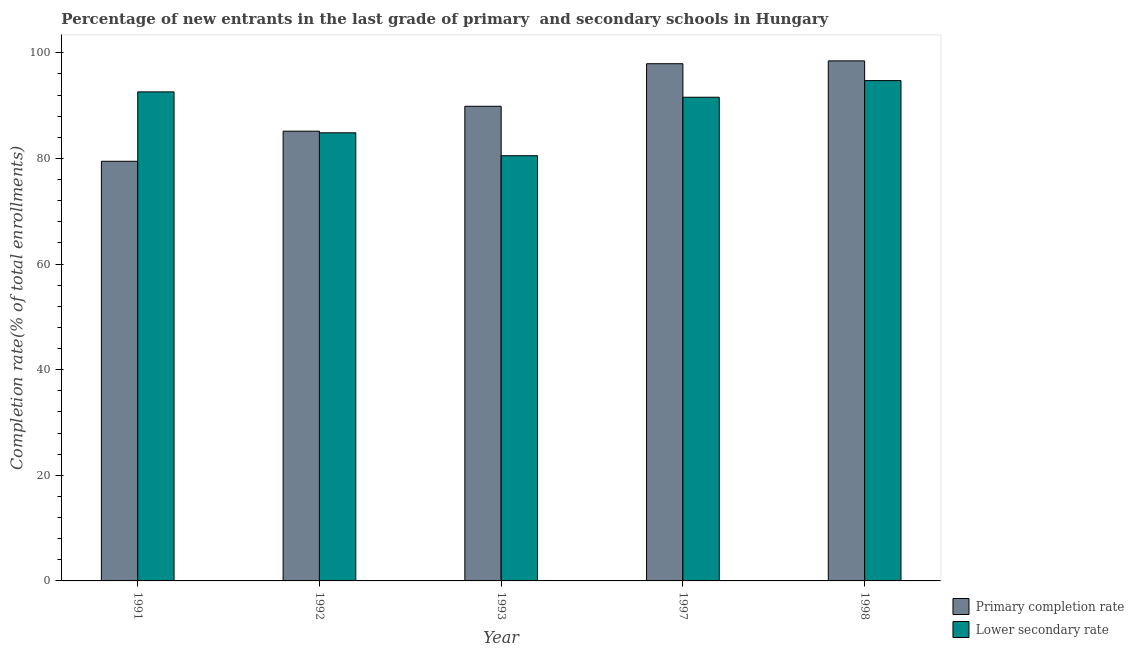How many different coloured bars are there?
Keep it short and to the point. 2. Are the number of bars per tick equal to the number of legend labels?
Give a very brief answer. Yes. How many bars are there on the 2nd tick from the left?
Keep it short and to the point. 2. What is the label of the 3rd group of bars from the left?
Your answer should be compact. 1993. In how many cases, is the number of bars for a given year not equal to the number of legend labels?
Give a very brief answer. 0. What is the completion rate in primary schools in 1992?
Your answer should be compact. 85.17. Across all years, what is the maximum completion rate in secondary schools?
Your response must be concise. 94.74. Across all years, what is the minimum completion rate in primary schools?
Your answer should be very brief. 79.47. In which year was the completion rate in secondary schools maximum?
Your answer should be very brief. 1998. In which year was the completion rate in secondary schools minimum?
Keep it short and to the point. 1993. What is the total completion rate in secondary schools in the graph?
Your answer should be compact. 444.32. What is the difference between the completion rate in secondary schools in 1991 and that in 1992?
Ensure brevity in your answer.  7.75. What is the difference between the completion rate in secondary schools in 1991 and the completion rate in primary schools in 1992?
Provide a succinct answer. 7.75. What is the average completion rate in secondary schools per year?
Make the answer very short. 88.86. In the year 1998, what is the difference between the completion rate in secondary schools and completion rate in primary schools?
Offer a terse response. 0. What is the ratio of the completion rate in secondary schools in 1997 to that in 1998?
Offer a terse response. 0.97. Is the difference between the completion rate in primary schools in 1991 and 1998 greater than the difference between the completion rate in secondary schools in 1991 and 1998?
Make the answer very short. No. What is the difference between the highest and the second highest completion rate in primary schools?
Your response must be concise. 0.54. What is the difference between the highest and the lowest completion rate in primary schools?
Your answer should be very brief. 19.01. What does the 1st bar from the left in 1991 represents?
Make the answer very short. Primary completion rate. What does the 2nd bar from the right in 1997 represents?
Your answer should be compact. Primary completion rate. How many years are there in the graph?
Offer a terse response. 5. Where does the legend appear in the graph?
Your answer should be very brief. Bottom right. How many legend labels are there?
Your response must be concise. 2. How are the legend labels stacked?
Offer a terse response. Vertical. What is the title of the graph?
Make the answer very short. Percentage of new entrants in the last grade of primary  and secondary schools in Hungary. Does "Research and Development" appear as one of the legend labels in the graph?
Ensure brevity in your answer.  No. What is the label or title of the Y-axis?
Provide a succinct answer. Completion rate(% of total enrollments). What is the Completion rate(% of total enrollments) of Primary completion rate in 1991?
Your answer should be very brief. 79.47. What is the Completion rate(% of total enrollments) of Lower secondary rate in 1991?
Make the answer very short. 92.61. What is the Completion rate(% of total enrollments) of Primary completion rate in 1992?
Ensure brevity in your answer.  85.17. What is the Completion rate(% of total enrollments) in Lower secondary rate in 1992?
Give a very brief answer. 84.86. What is the Completion rate(% of total enrollments) of Primary completion rate in 1993?
Your response must be concise. 89.88. What is the Completion rate(% of total enrollments) of Lower secondary rate in 1993?
Make the answer very short. 80.52. What is the Completion rate(% of total enrollments) in Primary completion rate in 1997?
Ensure brevity in your answer.  97.94. What is the Completion rate(% of total enrollments) of Lower secondary rate in 1997?
Your answer should be compact. 91.59. What is the Completion rate(% of total enrollments) in Primary completion rate in 1998?
Your answer should be compact. 98.48. What is the Completion rate(% of total enrollments) in Lower secondary rate in 1998?
Provide a short and direct response. 94.74. Across all years, what is the maximum Completion rate(% of total enrollments) of Primary completion rate?
Your response must be concise. 98.48. Across all years, what is the maximum Completion rate(% of total enrollments) in Lower secondary rate?
Ensure brevity in your answer.  94.74. Across all years, what is the minimum Completion rate(% of total enrollments) in Primary completion rate?
Give a very brief answer. 79.47. Across all years, what is the minimum Completion rate(% of total enrollments) of Lower secondary rate?
Offer a terse response. 80.52. What is the total Completion rate(% of total enrollments) in Primary completion rate in the graph?
Offer a very short reply. 450.93. What is the total Completion rate(% of total enrollments) in Lower secondary rate in the graph?
Offer a very short reply. 444.32. What is the difference between the Completion rate(% of total enrollments) of Primary completion rate in 1991 and that in 1992?
Give a very brief answer. -5.7. What is the difference between the Completion rate(% of total enrollments) in Lower secondary rate in 1991 and that in 1992?
Offer a very short reply. 7.75. What is the difference between the Completion rate(% of total enrollments) in Primary completion rate in 1991 and that in 1993?
Your answer should be compact. -10.42. What is the difference between the Completion rate(% of total enrollments) of Lower secondary rate in 1991 and that in 1993?
Your answer should be compact. 12.09. What is the difference between the Completion rate(% of total enrollments) in Primary completion rate in 1991 and that in 1997?
Your answer should be compact. -18.47. What is the difference between the Completion rate(% of total enrollments) in Lower secondary rate in 1991 and that in 1997?
Your response must be concise. 1.01. What is the difference between the Completion rate(% of total enrollments) in Primary completion rate in 1991 and that in 1998?
Make the answer very short. -19.01. What is the difference between the Completion rate(% of total enrollments) in Lower secondary rate in 1991 and that in 1998?
Make the answer very short. -2.14. What is the difference between the Completion rate(% of total enrollments) of Primary completion rate in 1992 and that in 1993?
Provide a succinct answer. -4.71. What is the difference between the Completion rate(% of total enrollments) in Lower secondary rate in 1992 and that in 1993?
Your answer should be compact. 4.34. What is the difference between the Completion rate(% of total enrollments) of Primary completion rate in 1992 and that in 1997?
Provide a short and direct response. -12.77. What is the difference between the Completion rate(% of total enrollments) in Lower secondary rate in 1992 and that in 1997?
Offer a very short reply. -6.74. What is the difference between the Completion rate(% of total enrollments) in Primary completion rate in 1992 and that in 1998?
Make the answer very short. -13.31. What is the difference between the Completion rate(% of total enrollments) in Lower secondary rate in 1992 and that in 1998?
Provide a short and direct response. -9.89. What is the difference between the Completion rate(% of total enrollments) of Primary completion rate in 1993 and that in 1997?
Offer a terse response. -8.06. What is the difference between the Completion rate(% of total enrollments) of Lower secondary rate in 1993 and that in 1997?
Provide a succinct answer. -11.08. What is the difference between the Completion rate(% of total enrollments) of Primary completion rate in 1993 and that in 1998?
Provide a succinct answer. -8.6. What is the difference between the Completion rate(% of total enrollments) of Lower secondary rate in 1993 and that in 1998?
Offer a very short reply. -14.23. What is the difference between the Completion rate(% of total enrollments) of Primary completion rate in 1997 and that in 1998?
Provide a short and direct response. -0.54. What is the difference between the Completion rate(% of total enrollments) in Lower secondary rate in 1997 and that in 1998?
Give a very brief answer. -3.15. What is the difference between the Completion rate(% of total enrollments) of Primary completion rate in 1991 and the Completion rate(% of total enrollments) of Lower secondary rate in 1992?
Ensure brevity in your answer.  -5.39. What is the difference between the Completion rate(% of total enrollments) in Primary completion rate in 1991 and the Completion rate(% of total enrollments) in Lower secondary rate in 1993?
Your response must be concise. -1.05. What is the difference between the Completion rate(% of total enrollments) of Primary completion rate in 1991 and the Completion rate(% of total enrollments) of Lower secondary rate in 1997?
Your answer should be compact. -12.13. What is the difference between the Completion rate(% of total enrollments) in Primary completion rate in 1991 and the Completion rate(% of total enrollments) in Lower secondary rate in 1998?
Your answer should be very brief. -15.28. What is the difference between the Completion rate(% of total enrollments) of Primary completion rate in 1992 and the Completion rate(% of total enrollments) of Lower secondary rate in 1993?
Keep it short and to the point. 4.65. What is the difference between the Completion rate(% of total enrollments) of Primary completion rate in 1992 and the Completion rate(% of total enrollments) of Lower secondary rate in 1997?
Your answer should be compact. -6.43. What is the difference between the Completion rate(% of total enrollments) in Primary completion rate in 1992 and the Completion rate(% of total enrollments) in Lower secondary rate in 1998?
Your response must be concise. -9.58. What is the difference between the Completion rate(% of total enrollments) in Primary completion rate in 1993 and the Completion rate(% of total enrollments) in Lower secondary rate in 1997?
Keep it short and to the point. -1.71. What is the difference between the Completion rate(% of total enrollments) in Primary completion rate in 1993 and the Completion rate(% of total enrollments) in Lower secondary rate in 1998?
Provide a succinct answer. -4.86. What is the difference between the Completion rate(% of total enrollments) of Primary completion rate in 1997 and the Completion rate(% of total enrollments) of Lower secondary rate in 1998?
Your answer should be very brief. 3.19. What is the average Completion rate(% of total enrollments) in Primary completion rate per year?
Give a very brief answer. 90.19. What is the average Completion rate(% of total enrollments) in Lower secondary rate per year?
Your answer should be very brief. 88.86. In the year 1991, what is the difference between the Completion rate(% of total enrollments) of Primary completion rate and Completion rate(% of total enrollments) of Lower secondary rate?
Keep it short and to the point. -13.14. In the year 1992, what is the difference between the Completion rate(% of total enrollments) of Primary completion rate and Completion rate(% of total enrollments) of Lower secondary rate?
Keep it short and to the point. 0.31. In the year 1993, what is the difference between the Completion rate(% of total enrollments) in Primary completion rate and Completion rate(% of total enrollments) in Lower secondary rate?
Offer a very short reply. 9.36. In the year 1997, what is the difference between the Completion rate(% of total enrollments) in Primary completion rate and Completion rate(% of total enrollments) in Lower secondary rate?
Make the answer very short. 6.35. In the year 1998, what is the difference between the Completion rate(% of total enrollments) of Primary completion rate and Completion rate(% of total enrollments) of Lower secondary rate?
Offer a very short reply. 3.73. What is the ratio of the Completion rate(% of total enrollments) in Primary completion rate in 1991 to that in 1992?
Your answer should be very brief. 0.93. What is the ratio of the Completion rate(% of total enrollments) in Lower secondary rate in 1991 to that in 1992?
Ensure brevity in your answer.  1.09. What is the ratio of the Completion rate(% of total enrollments) of Primary completion rate in 1991 to that in 1993?
Ensure brevity in your answer.  0.88. What is the ratio of the Completion rate(% of total enrollments) in Lower secondary rate in 1991 to that in 1993?
Give a very brief answer. 1.15. What is the ratio of the Completion rate(% of total enrollments) in Primary completion rate in 1991 to that in 1997?
Keep it short and to the point. 0.81. What is the ratio of the Completion rate(% of total enrollments) of Lower secondary rate in 1991 to that in 1997?
Ensure brevity in your answer.  1.01. What is the ratio of the Completion rate(% of total enrollments) in Primary completion rate in 1991 to that in 1998?
Offer a very short reply. 0.81. What is the ratio of the Completion rate(% of total enrollments) of Lower secondary rate in 1991 to that in 1998?
Your answer should be very brief. 0.98. What is the ratio of the Completion rate(% of total enrollments) in Primary completion rate in 1992 to that in 1993?
Your answer should be compact. 0.95. What is the ratio of the Completion rate(% of total enrollments) in Lower secondary rate in 1992 to that in 1993?
Provide a succinct answer. 1.05. What is the ratio of the Completion rate(% of total enrollments) of Primary completion rate in 1992 to that in 1997?
Offer a very short reply. 0.87. What is the ratio of the Completion rate(% of total enrollments) in Lower secondary rate in 1992 to that in 1997?
Keep it short and to the point. 0.93. What is the ratio of the Completion rate(% of total enrollments) in Primary completion rate in 1992 to that in 1998?
Offer a very short reply. 0.86. What is the ratio of the Completion rate(% of total enrollments) in Lower secondary rate in 1992 to that in 1998?
Provide a succinct answer. 0.9. What is the ratio of the Completion rate(% of total enrollments) in Primary completion rate in 1993 to that in 1997?
Keep it short and to the point. 0.92. What is the ratio of the Completion rate(% of total enrollments) of Lower secondary rate in 1993 to that in 1997?
Provide a short and direct response. 0.88. What is the ratio of the Completion rate(% of total enrollments) in Primary completion rate in 1993 to that in 1998?
Provide a succinct answer. 0.91. What is the ratio of the Completion rate(% of total enrollments) of Lower secondary rate in 1993 to that in 1998?
Offer a terse response. 0.85. What is the ratio of the Completion rate(% of total enrollments) in Primary completion rate in 1997 to that in 1998?
Ensure brevity in your answer.  0.99. What is the ratio of the Completion rate(% of total enrollments) in Lower secondary rate in 1997 to that in 1998?
Provide a short and direct response. 0.97. What is the difference between the highest and the second highest Completion rate(% of total enrollments) in Primary completion rate?
Provide a succinct answer. 0.54. What is the difference between the highest and the second highest Completion rate(% of total enrollments) of Lower secondary rate?
Your response must be concise. 2.14. What is the difference between the highest and the lowest Completion rate(% of total enrollments) in Primary completion rate?
Ensure brevity in your answer.  19.01. What is the difference between the highest and the lowest Completion rate(% of total enrollments) in Lower secondary rate?
Keep it short and to the point. 14.23. 